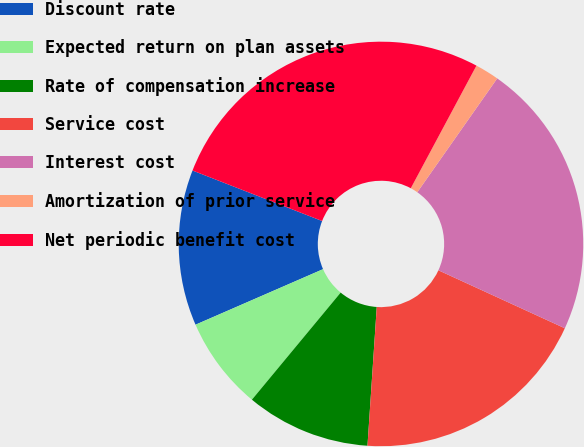Convert chart. <chart><loc_0><loc_0><loc_500><loc_500><pie_chart><fcel>Discount rate<fcel>Expected return on plan assets<fcel>Rate of compensation increase<fcel>Service cost<fcel>Interest cost<fcel>Amortization of prior service<fcel>Net periodic benefit cost<nl><fcel>12.45%<fcel>7.45%<fcel>9.95%<fcel>19.22%<fcel>22.1%<fcel>1.92%<fcel>26.91%<nl></chart> 